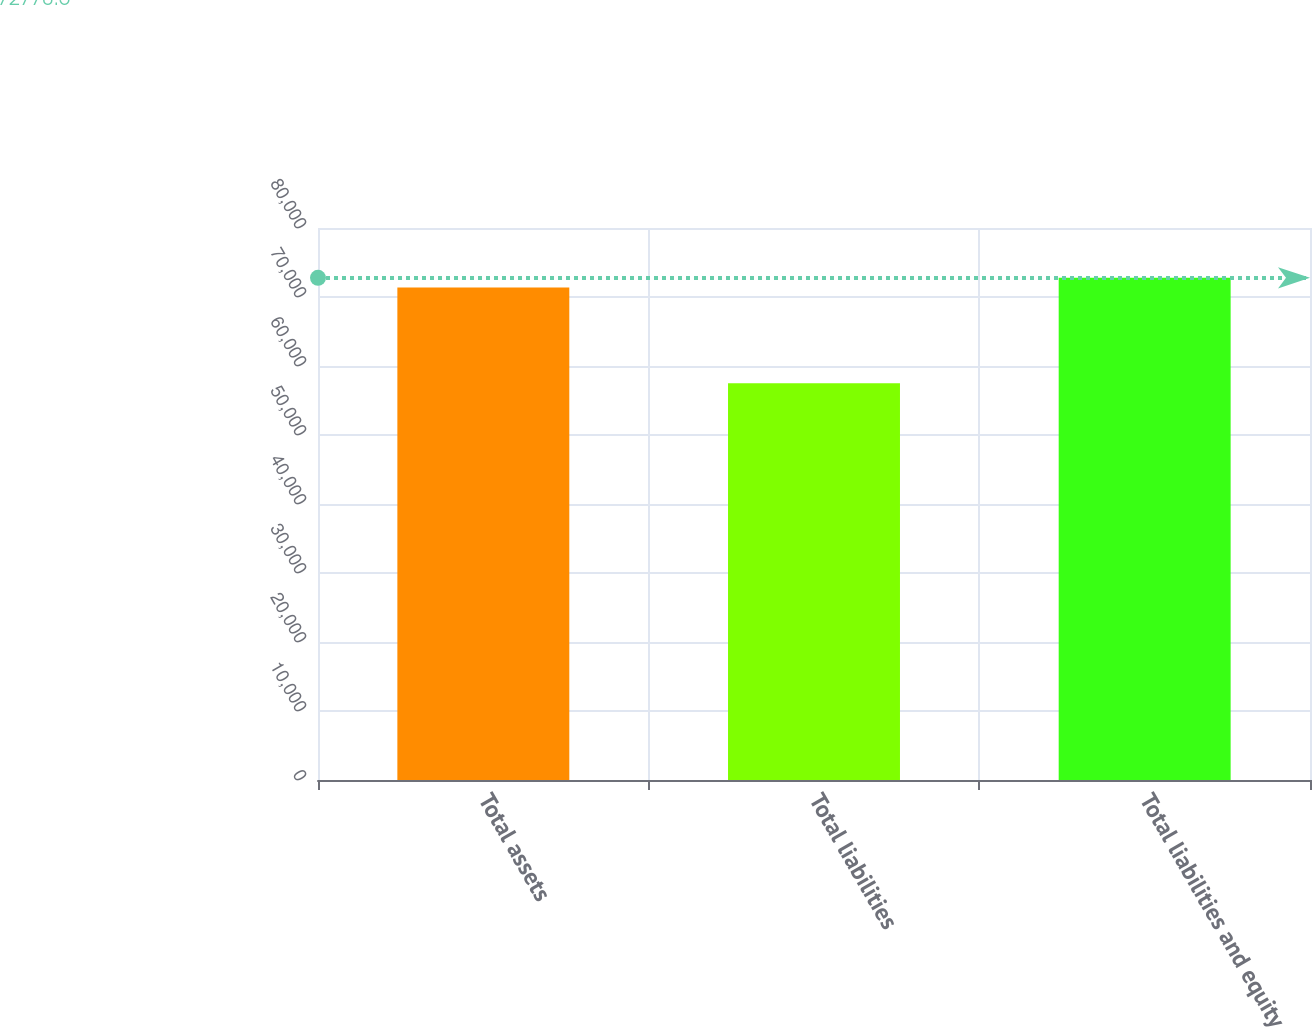Convert chart. <chart><loc_0><loc_0><loc_500><loc_500><bar_chart><fcel>Total assets<fcel>Total liabilities<fcel>Total liabilities and equity<nl><fcel>71389<fcel>57494<fcel>72778.5<nl></chart> 